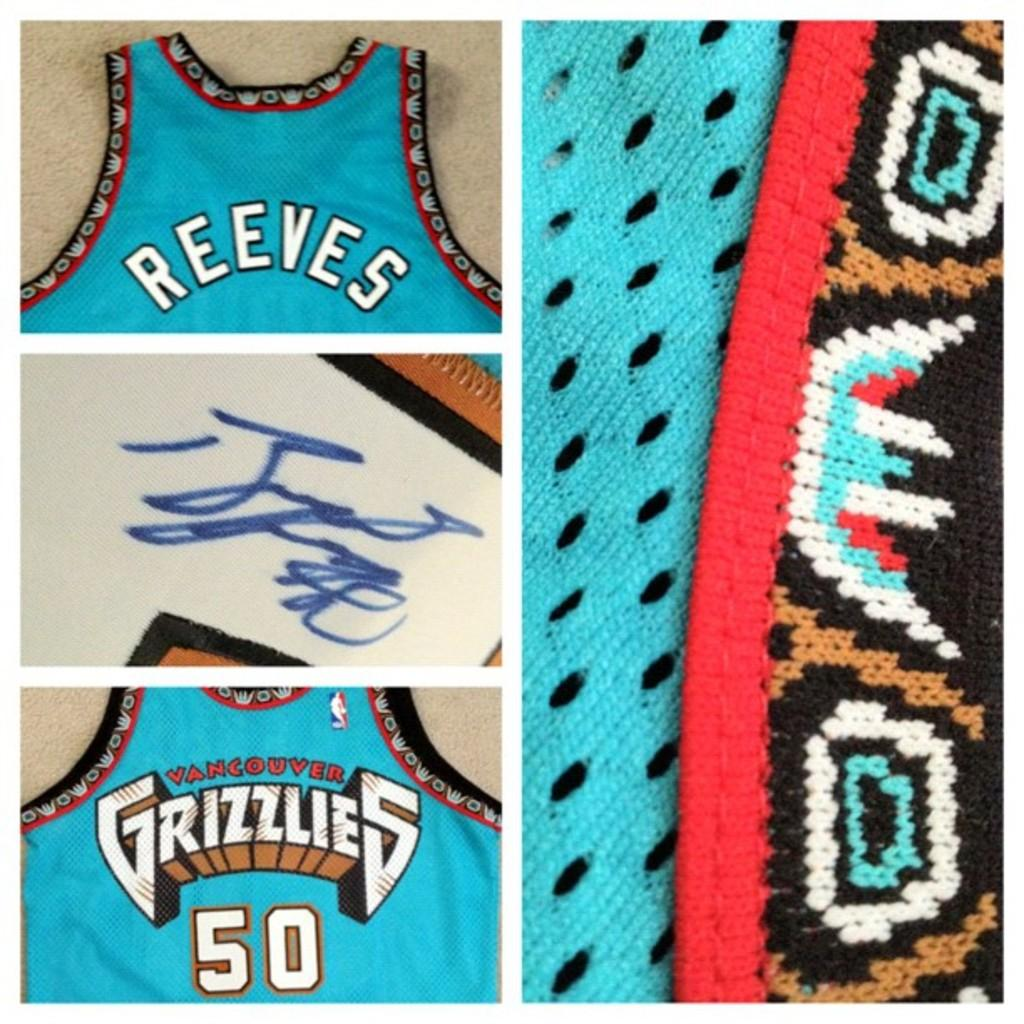<image>
Describe the image concisely. A blue Vancouver Grizzlies jersey autographed by Reeves 